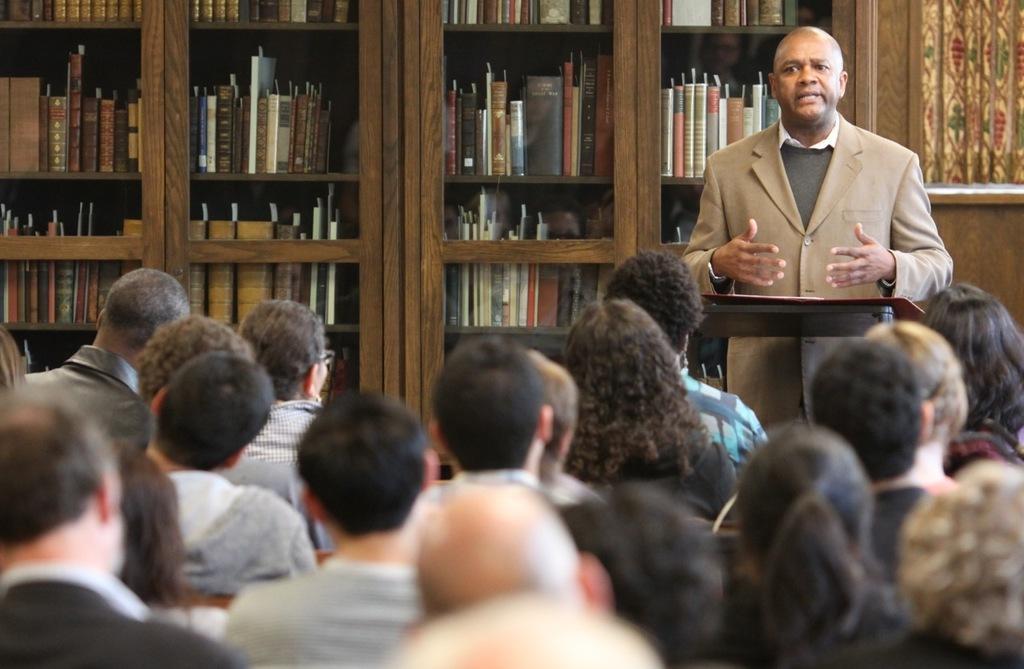Could you give a brief overview of what you see in this image? In the foreground of the picture there are people sitting. On the right there is a person standing, in front of a podium and talking. In the background there are books in bookshelves. 